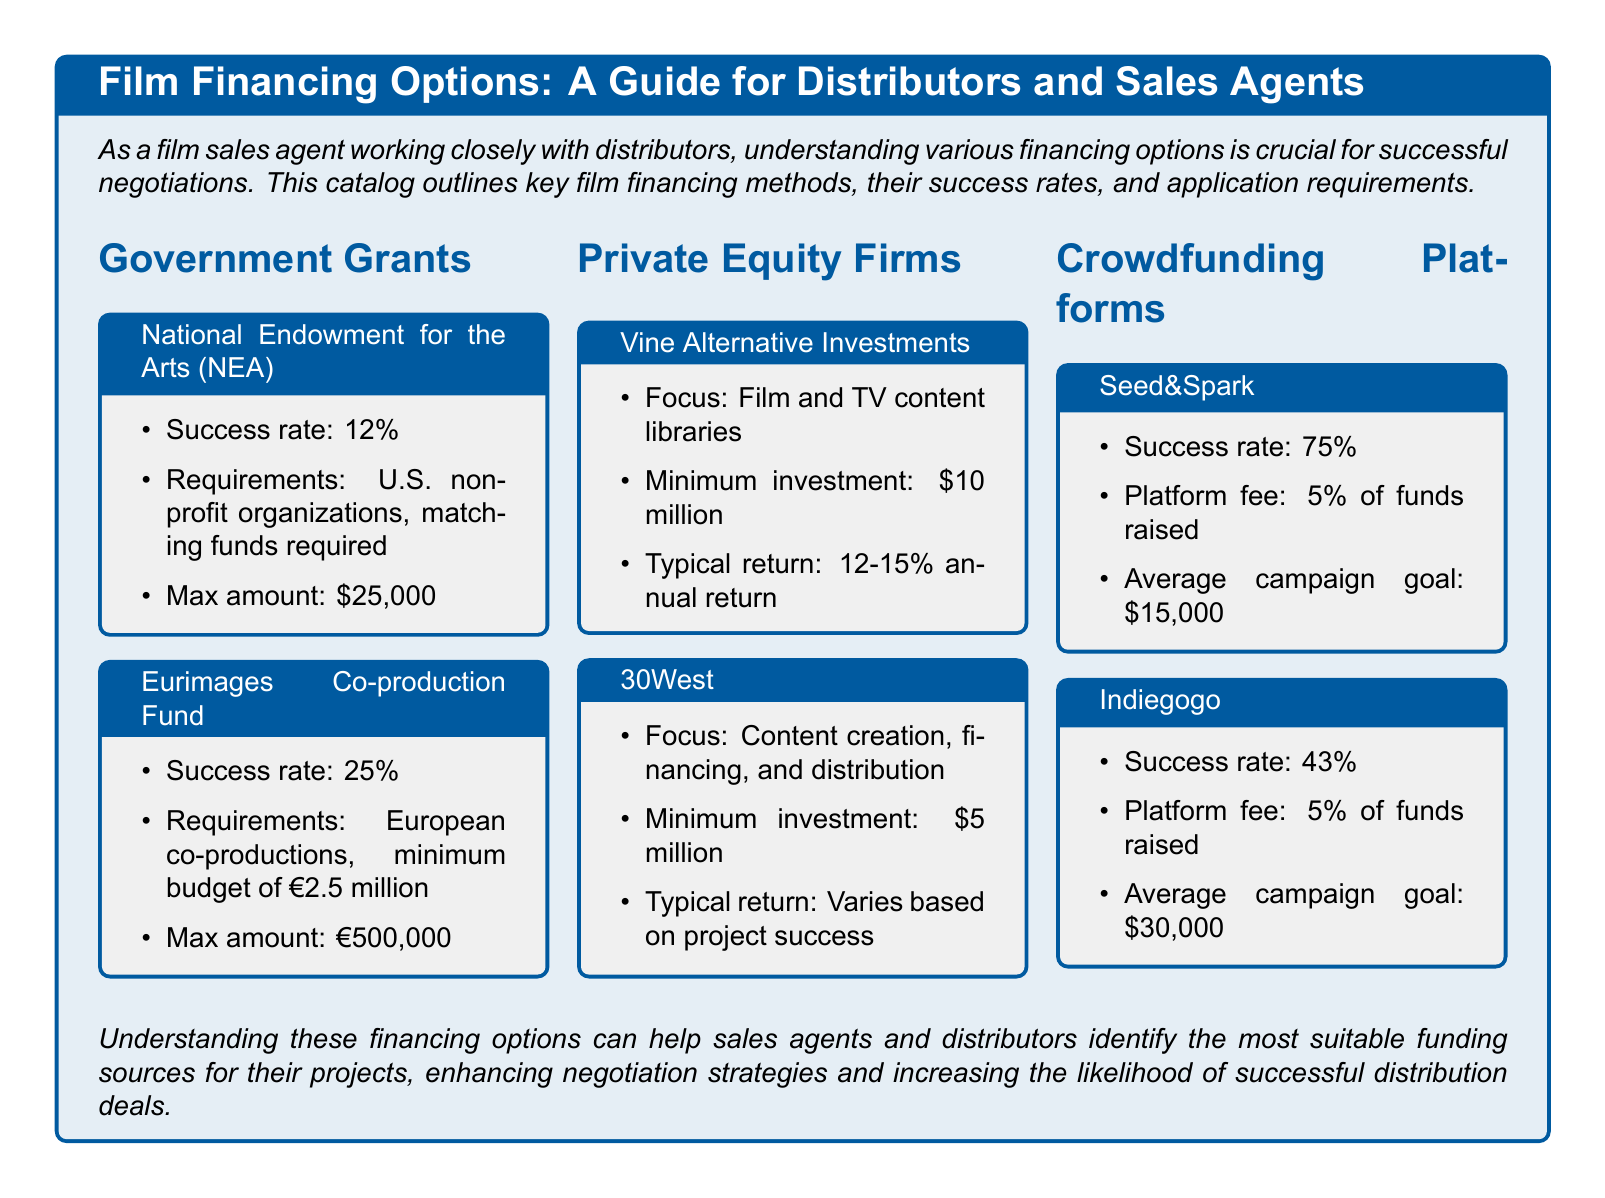What is the success rate of the National Endowment for the Arts? The success rate for the National Endowment for the Arts is listed in the document as 12%.
Answer: 12% What is the maximum amount available from the Eurimages Co-production Fund? The maximum amount for the Eurimages Co-production Fund is stated as €500,000.
Answer: €500,000 What is the average campaign goal on Seed&Spark? The average campaign goal on Seed&Spark is given as $15,000.
Answer: $15,000 What is the minimum investment for Vine Alternative Investments? The minimum investment required for Vine Alternative Investments is listed as $10 million.
Answer: $10 million What defines the focus of 30West? The focus of 30West is described as content creation, financing, and distribution.
Answer: Content creation, financing, and distribution How does the success rate of Indiegogo compare to that of Seed&Spark? Indiegogo has a success rate of 43%, while Seed&Spark has a success rate of 75%, indicating that Seed&Spark is more successful.
Answer: Seed&Spark is more successful What is the platform fee for crowdfunding on Indiegogo? The document specifies that the platform fee for Indiegogo is 5% of funds raised.
Answer: 5% Which funding option has the highest success rate? The highest success rate mentioned in the document is for Seed&Spark at 75%.
Answer: Seed&Spark What type of organizations are eligible for the NEA grant? The eligible organizations for the NEA grant are U.S. non-profit organizations.
Answer: U.S. non-profit organizations 